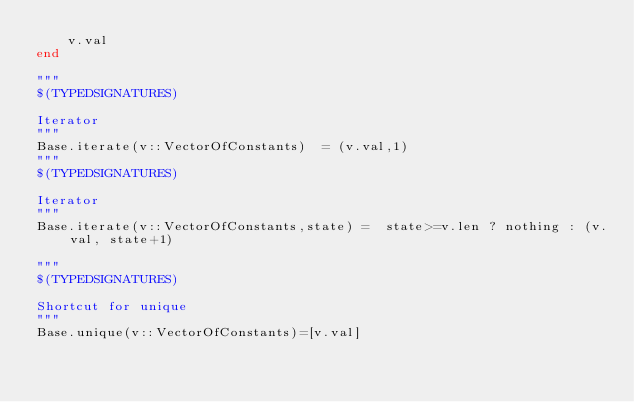Convert code to text. <code><loc_0><loc_0><loc_500><loc_500><_Julia_>    v.val
end

"""
$(TYPEDSIGNATURES)

Iterator
"""
Base.iterate(v::VectorOfConstants)  = (v.val,1)
"""
$(TYPEDSIGNATURES)

Iterator
"""
Base.iterate(v::VectorOfConstants,state) =  state>=v.len ? nothing : (v.val, state+1)

"""
$(TYPEDSIGNATURES)

Shortcut for unique
"""
Base.unique(v::VectorOfConstants)=[v.val]






</code> 